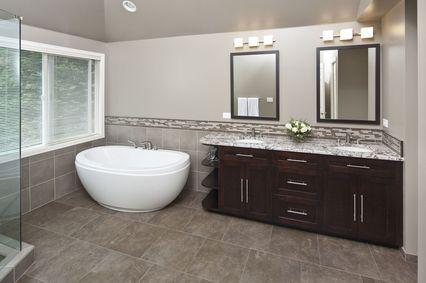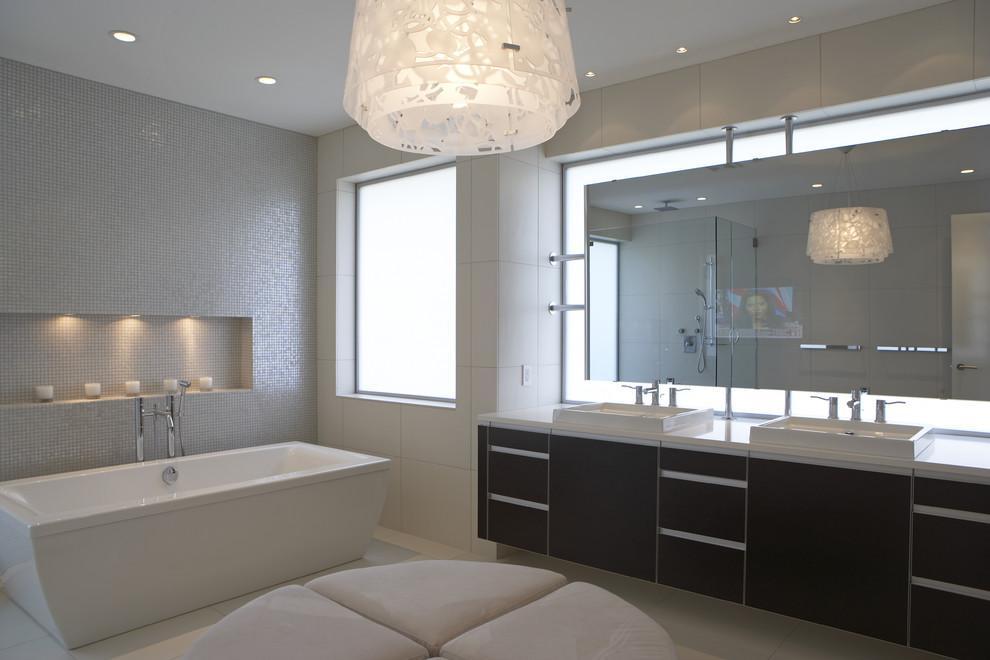The first image is the image on the left, the second image is the image on the right. Evaluate the accuracy of this statement regarding the images: "The flowers in the vase are pink.". Is it true? Answer yes or no. No. 